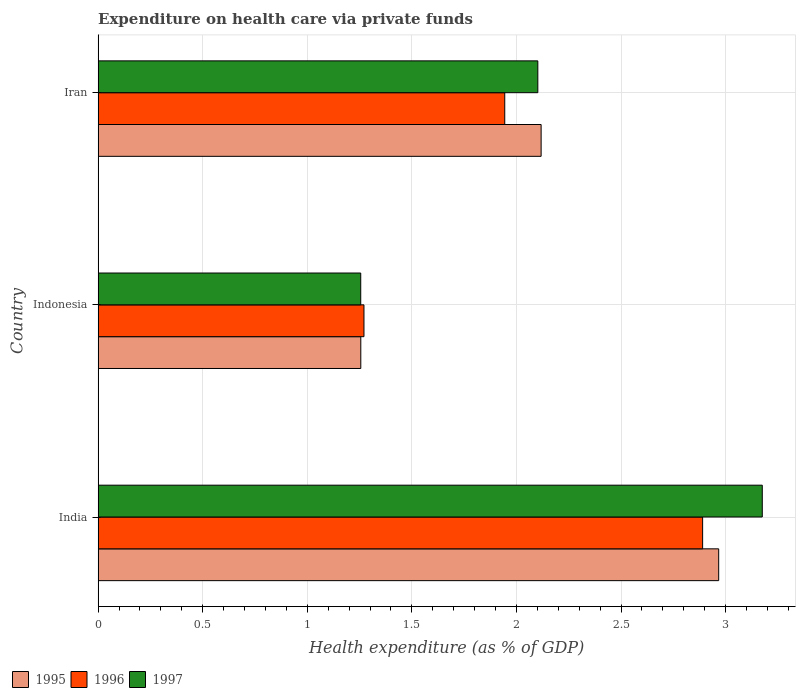How many groups of bars are there?
Offer a very short reply. 3. How many bars are there on the 3rd tick from the bottom?
Provide a succinct answer. 3. What is the label of the 1st group of bars from the top?
Keep it short and to the point. Iran. In how many cases, is the number of bars for a given country not equal to the number of legend labels?
Offer a terse response. 0. What is the expenditure made on health care in 1996 in Indonesia?
Make the answer very short. 1.27. Across all countries, what is the maximum expenditure made on health care in 1995?
Your answer should be compact. 2.97. Across all countries, what is the minimum expenditure made on health care in 1997?
Give a very brief answer. 1.26. In which country was the expenditure made on health care in 1995 maximum?
Keep it short and to the point. India. In which country was the expenditure made on health care in 1995 minimum?
Give a very brief answer. Indonesia. What is the total expenditure made on health care in 1996 in the graph?
Offer a very short reply. 6.11. What is the difference between the expenditure made on health care in 1996 in India and that in Iran?
Your response must be concise. 0.95. What is the difference between the expenditure made on health care in 1997 in India and the expenditure made on health care in 1995 in Iran?
Ensure brevity in your answer.  1.06. What is the average expenditure made on health care in 1995 per country?
Offer a terse response. 2.11. What is the difference between the expenditure made on health care in 1995 and expenditure made on health care in 1997 in India?
Offer a terse response. -0.21. In how many countries, is the expenditure made on health care in 1997 greater than 2.8 %?
Your response must be concise. 1. What is the ratio of the expenditure made on health care in 1995 in Indonesia to that in Iran?
Make the answer very short. 0.59. What is the difference between the highest and the second highest expenditure made on health care in 1996?
Your answer should be very brief. 0.95. What is the difference between the highest and the lowest expenditure made on health care in 1995?
Make the answer very short. 1.71. In how many countries, is the expenditure made on health care in 1995 greater than the average expenditure made on health care in 1995 taken over all countries?
Give a very brief answer. 2. Is the sum of the expenditure made on health care in 1995 in India and Iran greater than the maximum expenditure made on health care in 1996 across all countries?
Offer a very short reply. Yes. Is it the case that in every country, the sum of the expenditure made on health care in 1997 and expenditure made on health care in 1995 is greater than the expenditure made on health care in 1996?
Offer a terse response. Yes. Are all the bars in the graph horizontal?
Offer a terse response. Yes. Are the values on the major ticks of X-axis written in scientific E-notation?
Ensure brevity in your answer.  No. Where does the legend appear in the graph?
Offer a terse response. Bottom left. What is the title of the graph?
Your answer should be very brief. Expenditure on health care via private funds. Does "1994" appear as one of the legend labels in the graph?
Your answer should be very brief. No. What is the label or title of the X-axis?
Your answer should be compact. Health expenditure (as % of GDP). What is the label or title of the Y-axis?
Your answer should be very brief. Country. What is the Health expenditure (as % of GDP) in 1995 in India?
Offer a terse response. 2.97. What is the Health expenditure (as % of GDP) of 1996 in India?
Offer a very short reply. 2.89. What is the Health expenditure (as % of GDP) in 1997 in India?
Keep it short and to the point. 3.18. What is the Health expenditure (as % of GDP) in 1995 in Indonesia?
Give a very brief answer. 1.26. What is the Health expenditure (as % of GDP) in 1996 in Indonesia?
Provide a short and direct response. 1.27. What is the Health expenditure (as % of GDP) in 1997 in Indonesia?
Give a very brief answer. 1.26. What is the Health expenditure (as % of GDP) in 1995 in Iran?
Provide a short and direct response. 2.12. What is the Health expenditure (as % of GDP) in 1996 in Iran?
Provide a succinct answer. 1.94. What is the Health expenditure (as % of GDP) in 1997 in Iran?
Provide a short and direct response. 2.1. Across all countries, what is the maximum Health expenditure (as % of GDP) in 1995?
Keep it short and to the point. 2.97. Across all countries, what is the maximum Health expenditure (as % of GDP) of 1996?
Offer a terse response. 2.89. Across all countries, what is the maximum Health expenditure (as % of GDP) in 1997?
Your answer should be compact. 3.18. Across all countries, what is the minimum Health expenditure (as % of GDP) of 1995?
Ensure brevity in your answer.  1.26. Across all countries, what is the minimum Health expenditure (as % of GDP) in 1996?
Keep it short and to the point. 1.27. Across all countries, what is the minimum Health expenditure (as % of GDP) of 1997?
Give a very brief answer. 1.26. What is the total Health expenditure (as % of GDP) in 1995 in the graph?
Your response must be concise. 6.34. What is the total Health expenditure (as % of GDP) in 1996 in the graph?
Provide a short and direct response. 6.11. What is the total Health expenditure (as % of GDP) of 1997 in the graph?
Your answer should be very brief. 6.53. What is the difference between the Health expenditure (as % of GDP) in 1995 in India and that in Indonesia?
Provide a short and direct response. 1.71. What is the difference between the Health expenditure (as % of GDP) in 1996 in India and that in Indonesia?
Give a very brief answer. 1.62. What is the difference between the Health expenditure (as % of GDP) of 1997 in India and that in Indonesia?
Make the answer very short. 1.92. What is the difference between the Health expenditure (as % of GDP) of 1995 in India and that in Iran?
Make the answer very short. 0.85. What is the difference between the Health expenditure (as % of GDP) of 1996 in India and that in Iran?
Your answer should be very brief. 0.95. What is the difference between the Health expenditure (as % of GDP) of 1997 in India and that in Iran?
Your answer should be compact. 1.07. What is the difference between the Health expenditure (as % of GDP) of 1995 in Indonesia and that in Iran?
Provide a short and direct response. -0.86. What is the difference between the Health expenditure (as % of GDP) of 1996 in Indonesia and that in Iran?
Your answer should be very brief. -0.67. What is the difference between the Health expenditure (as % of GDP) of 1997 in Indonesia and that in Iran?
Your answer should be compact. -0.85. What is the difference between the Health expenditure (as % of GDP) of 1995 in India and the Health expenditure (as % of GDP) of 1996 in Indonesia?
Provide a short and direct response. 1.7. What is the difference between the Health expenditure (as % of GDP) in 1995 in India and the Health expenditure (as % of GDP) in 1997 in Indonesia?
Your answer should be compact. 1.71. What is the difference between the Health expenditure (as % of GDP) in 1996 in India and the Health expenditure (as % of GDP) in 1997 in Indonesia?
Give a very brief answer. 1.63. What is the difference between the Health expenditure (as % of GDP) in 1995 in India and the Health expenditure (as % of GDP) in 1996 in Iran?
Provide a succinct answer. 1.02. What is the difference between the Health expenditure (as % of GDP) of 1995 in India and the Health expenditure (as % of GDP) of 1997 in Iran?
Your answer should be compact. 0.86. What is the difference between the Health expenditure (as % of GDP) in 1996 in India and the Health expenditure (as % of GDP) in 1997 in Iran?
Keep it short and to the point. 0.79. What is the difference between the Health expenditure (as % of GDP) of 1995 in Indonesia and the Health expenditure (as % of GDP) of 1996 in Iran?
Provide a succinct answer. -0.69. What is the difference between the Health expenditure (as % of GDP) in 1995 in Indonesia and the Health expenditure (as % of GDP) in 1997 in Iran?
Keep it short and to the point. -0.85. What is the difference between the Health expenditure (as % of GDP) of 1996 in Indonesia and the Health expenditure (as % of GDP) of 1997 in Iran?
Your response must be concise. -0.83. What is the average Health expenditure (as % of GDP) of 1995 per country?
Offer a terse response. 2.11. What is the average Health expenditure (as % of GDP) of 1996 per country?
Make the answer very short. 2.04. What is the average Health expenditure (as % of GDP) of 1997 per country?
Your answer should be compact. 2.18. What is the difference between the Health expenditure (as % of GDP) in 1995 and Health expenditure (as % of GDP) in 1996 in India?
Provide a succinct answer. 0.08. What is the difference between the Health expenditure (as % of GDP) of 1995 and Health expenditure (as % of GDP) of 1997 in India?
Your response must be concise. -0.21. What is the difference between the Health expenditure (as % of GDP) of 1996 and Health expenditure (as % of GDP) of 1997 in India?
Give a very brief answer. -0.29. What is the difference between the Health expenditure (as % of GDP) of 1995 and Health expenditure (as % of GDP) of 1996 in Indonesia?
Your answer should be very brief. -0.02. What is the difference between the Health expenditure (as % of GDP) in 1996 and Health expenditure (as % of GDP) in 1997 in Indonesia?
Ensure brevity in your answer.  0.02. What is the difference between the Health expenditure (as % of GDP) in 1995 and Health expenditure (as % of GDP) in 1996 in Iran?
Keep it short and to the point. 0.17. What is the difference between the Health expenditure (as % of GDP) of 1995 and Health expenditure (as % of GDP) of 1997 in Iran?
Offer a terse response. 0.02. What is the difference between the Health expenditure (as % of GDP) of 1996 and Health expenditure (as % of GDP) of 1997 in Iran?
Your response must be concise. -0.16. What is the ratio of the Health expenditure (as % of GDP) in 1995 in India to that in Indonesia?
Keep it short and to the point. 2.36. What is the ratio of the Health expenditure (as % of GDP) in 1996 in India to that in Indonesia?
Keep it short and to the point. 2.27. What is the ratio of the Health expenditure (as % of GDP) in 1997 in India to that in Indonesia?
Provide a short and direct response. 2.53. What is the ratio of the Health expenditure (as % of GDP) in 1995 in India to that in Iran?
Make the answer very short. 1.4. What is the ratio of the Health expenditure (as % of GDP) in 1996 in India to that in Iran?
Your answer should be compact. 1.49. What is the ratio of the Health expenditure (as % of GDP) of 1997 in India to that in Iran?
Offer a very short reply. 1.51. What is the ratio of the Health expenditure (as % of GDP) in 1995 in Indonesia to that in Iran?
Your response must be concise. 0.59. What is the ratio of the Health expenditure (as % of GDP) of 1996 in Indonesia to that in Iran?
Provide a short and direct response. 0.65. What is the ratio of the Health expenditure (as % of GDP) of 1997 in Indonesia to that in Iran?
Keep it short and to the point. 0.6. What is the difference between the highest and the second highest Health expenditure (as % of GDP) in 1995?
Ensure brevity in your answer.  0.85. What is the difference between the highest and the second highest Health expenditure (as % of GDP) in 1996?
Your response must be concise. 0.95. What is the difference between the highest and the second highest Health expenditure (as % of GDP) in 1997?
Provide a short and direct response. 1.07. What is the difference between the highest and the lowest Health expenditure (as % of GDP) of 1995?
Provide a short and direct response. 1.71. What is the difference between the highest and the lowest Health expenditure (as % of GDP) in 1996?
Give a very brief answer. 1.62. What is the difference between the highest and the lowest Health expenditure (as % of GDP) of 1997?
Your response must be concise. 1.92. 